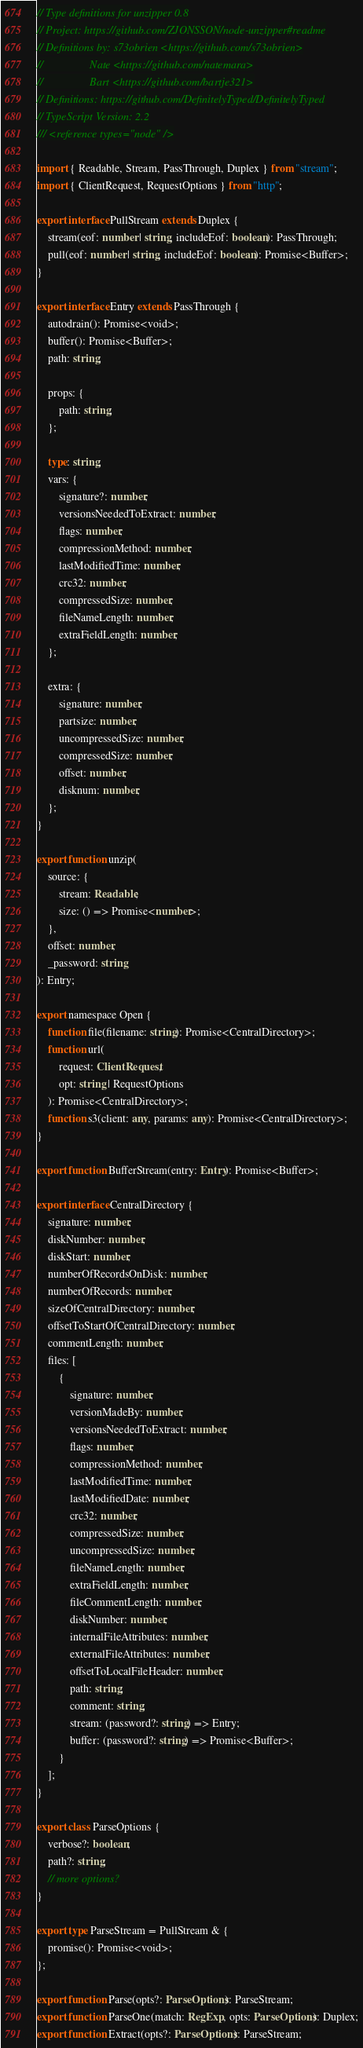<code> <loc_0><loc_0><loc_500><loc_500><_TypeScript_>// Type definitions for unzipper 0.8
// Project: https://github.com/ZJONSSON/node-unzipper#readme
// Definitions by: s73obrien <https://github.com/s73obrien>
//                 Nate <https://github.com/natemara>
//                 Bart <https://github.com/bartje321>
// Definitions: https://github.com/DefinitelyTyped/DefinitelyTyped
// TypeScript Version: 2.2
/// <reference types="node" />

import { Readable, Stream, PassThrough, Duplex } from "stream";
import { ClientRequest, RequestOptions } from "http";

export interface PullStream extends Duplex {
    stream(eof: number | string, includeEof: boolean): PassThrough;
    pull(eof: number | string, includeEof: boolean): Promise<Buffer>;
}

export interface Entry extends PassThrough {
    autodrain(): Promise<void>;
    buffer(): Promise<Buffer>;
    path: string;

    props: {
        path: string;
    };

    type: string;
    vars: {
        signature?: number;
        versionsNeededToExtract: number;
        flags: number;
        compressionMethod: number;
        lastModifiedTime: number;
        crc32: number;
        compressedSize: number;
        fileNameLength: number;
        extraFieldLength: number;
    };

    extra: {
        signature: number;
        partsize: number;
        uncompressedSize: number;
        compressedSize: number;
        offset: number;
        disknum: number;
    };
}

export function unzip(
    source: {
        stream: Readable;
        size: () => Promise<number>;
    },
    offset: number,
    _password: string
): Entry;

export namespace Open {
    function file(filename: string): Promise<CentralDirectory>;
    function url(
        request: ClientRequest,
        opt: string | RequestOptions
    ): Promise<CentralDirectory>;
    function s3(client: any, params: any): Promise<CentralDirectory>;
}

export function BufferStream(entry: Entry): Promise<Buffer>;

export interface CentralDirectory {
    signature: number;
    diskNumber: number;
    diskStart: number;
    numberOfRecordsOnDisk: number;
    numberOfRecords: number;
    sizeOfCentralDirectory: number;
    offsetToStartOfCentralDirectory: number;
    commentLength: number;
    files: [
        {
            signature: number;
            versionMadeBy: number;
            versionsNeededToExtract: number;
            flags: number;
            compressionMethod: number;
            lastModifiedTime: number;
            lastModifiedDate: number;
            crc32: number;
            compressedSize: number;
            uncompressedSize: number;
            fileNameLength: number;
            extraFieldLength: number;
            fileCommentLength: number;
            diskNumber: number;
            internalFileAttributes: number;
            externalFileAttributes: number;
            offsetToLocalFileHeader: number;
            path: string;
            comment: string;
            stream: (password?: string) => Entry;
            buffer: (password?: string) => Promise<Buffer>;
        }
    ];
}

export class ParseOptions {
    verbose?: boolean;
    path?: string;
    // more options?
}

export type ParseStream = PullStream & {
    promise(): Promise<void>;
};

export function Parse(opts?: ParseOptions): ParseStream;
export function ParseOne(match: RegExp, opts: ParseOptions): Duplex;
export function Extract(opts?: ParseOptions): ParseStream;
</code> 